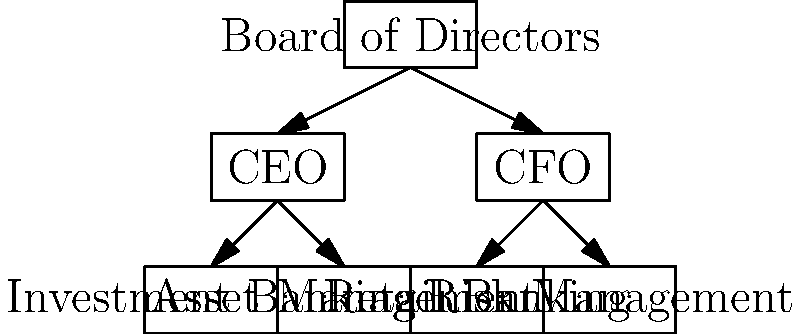In the organizational chart of a typical investment bank, which department is most likely to be responsible for managing the bank's exposure to market fluctuations and potential losses? To answer this question, let's analyze the organizational structure presented in the chart:

1. At the top, we have the Board of Directors, overseeing the entire organization.

2. Directly below are two key executive positions: CEO and CFO.

3. Under these executives, we see four main departments:
   a) Investment Banking
   b) Asset Management
   c) Retail Banking
   d) Risk Management

4. When considering which department is responsible for managing the bank's exposure to market fluctuations and potential losses, we need to think about the primary functions of each department:

   a) Investment Banking typically deals with corporate finance, mergers and acquisitions, and underwriting.
   b) Asset Management focuses on managing client investments and portfolios.
   c) Retail Banking handles consumer banking services.
   d) Risk Management is specifically tasked with identifying, assessing, and mitigating financial risks.

5. Given that market fluctuations and potential losses are key financial risks for an investment bank, the department most suited to handle these issues would be Risk Management.

6. The Risk Management department typically employs various tools and strategies to monitor and control the bank's exposure to market risks, credit risks, and operational risks.

Therefore, based on the organizational structure and the typical functions of each department, the Risk Management department is most likely responsible for managing the bank's exposure to market fluctuations and potential losses.
Answer: Risk Management 